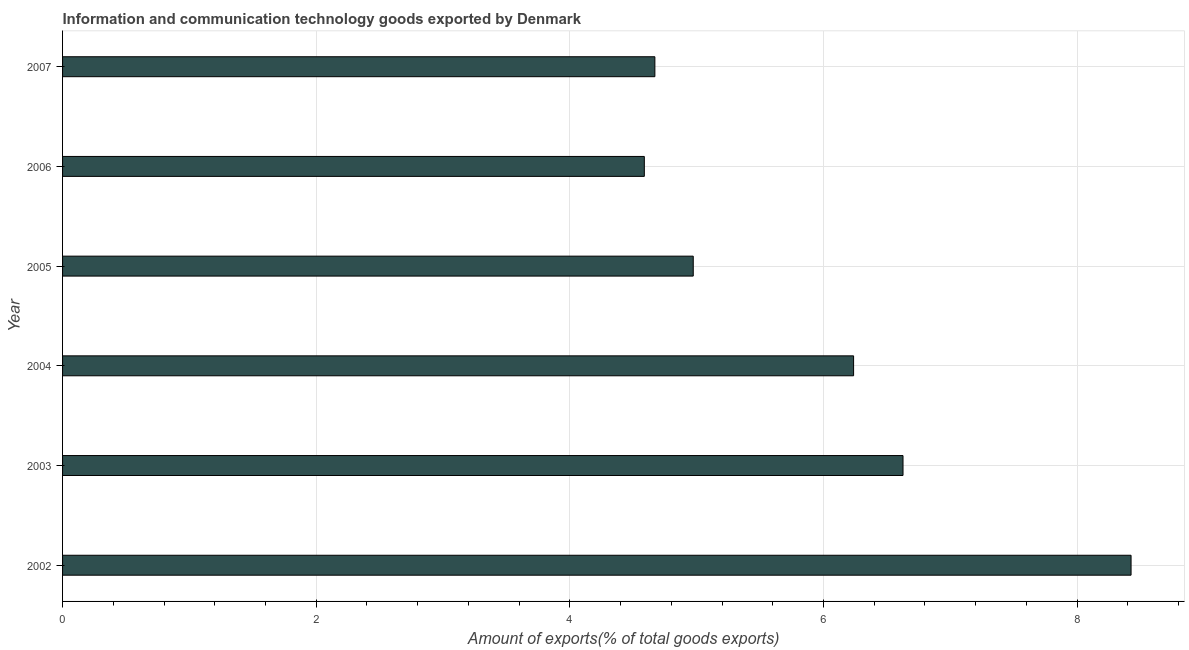Does the graph contain any zero values?
Make the answer very short. No. Does the graph contain grids?
Provide a succinct answer. Yes. What is the title of the graph?
Your answer should be compact. Information and communication technology goods exported by Denmark. What is the label or title of the X-axis?
Your answer should be very brief. Amount of exports(% of total goods exports). What is the amount of ict goods exports in 2006?
Offer a very short reply. 4.59. Across all years, what is the maximum amount of ict goods exports?
Your answer should be compact. 8.43. Across all years, what is the minimum amount of ict goods exports?
Your answer should be compact. 4.59. In which year was the amount of ict goods exports minimum?
Make the answer very short. 2006. What is the sum of the amount of ict goods exports?
Provide a succinct answer. 35.52. What is the difference between the amount of ict goods exports in 2003 and 2007?
Your answer should be very brief. 1.96. What is the average amount of ict goods exports per year?
Keep it short and to the point. 5.92. What is the median amount of ict goods exports?
Give a very brief answer. 5.61. In how many years, is the amount of ict goods exports greater than 2 %?
Your answer should be very brief. 6. What is the ratio of the amount of ict goods exports in 2002 to that in 2007?
Offer a terse response. 1.8. Is the amount of ict goods exports in 2002 less than that in 2005?
Your answer should be compact. No. What is the difference between the highest and the second highest amount of ict goods exports?
Your answer should be compact. 1.8. Is the sum of the amount of ict goods exports in 2005 and 2007 greater than the maximum amount of ict goods exports across all years?
Offer a very short reply. Yes. What is the difference between the highest and the lowest amount of ict goods exports?
Provide a succinct answer. 3.84. How many bars are there?
Offer a very short reply. 6. Are all the bars in the graph horizontal?
Offer a very short reply. Yes. How many years are there in the graph?
Your answer should be compact. 6. What is the Amount of exports(% of total goods exports) in 2002?
Give a very brief answer. 8.43. What is the Amount of exports(% of total goods exports) in 2003?
Give a very brief answer. 6.63. What is the Amount of exports(% of total goods exports) of 2004?
Your response must be concise. 6.24. What is the Amount of exports(% of total goods exports) in 2005?
Give a very brief answer. 4.97. What is the Amount of exports(% of total goods exports) in 2006?
Your response must be concise. 4.59. What is the Amount of exports(% of total goods exports) in 2007?
Keep it short and to the point. 4.67. What is the difference between the Amount of exports(% of total goods exports) in 2002 and 2003?
Make the answer very short. 1.8. What is the difference between the Amount of exports(% of total goods exports) in 2002 and 2004?
Give a very brief answer. 2.19. What is the difference between the Amount of exports(% of total goods exports) in 2002 and 2005?
Give a very brief answer. 3.45. What is the difference between the Amount of exports(% of total goods exports) in 2002 and 2006?
Make the answer very short. 3.84. What is the difference between the Amount of exports(% of total goods exports) in 2002 and 2007?
Keep it short and to the point. 3.75. What is the difference between the Amount of exports(% of total goods exports) in 2003 and 2004?
Your response must be concise. 0.39. What is the difference between the Amount of exports(% of total goods exports) in 2003 and 2005?
Your answer should be compact. 1.65. What is the difference between the Amount of exports(% of total goods exports) in 2003 and 2006?
Your answer should be compact. 2.04. What is the difference between the Amount of exports(% of total goods exports) in 2003 and 2007?
Your answer should be compact. 1.96. What is the difference between the Amount of exports(% of total goods exports) in 2004 and 2005?
Keep it short and to the point. 1.26. What is the difference between the Amount of exports(% of total goods exports) in 2004 and 2006?
Your answer should be very brief. 1.65. What is the difference between the Amount of exports(% of total goods exports) in 2004 and 2007?
Offer a terse response. 1.57. What is the difference between the Amount of exports(% of total goods exports) in 2005 and 2006?
Give a very brief answer. 0.39. What is the difference between the Amount of exports(% of total goods exports) in 2005 and 2007?
Your answer should be compact. 0.3. What is the difference between the Amount of exports(% of total goods exports) in 2006 and 2007?
Offer a very short reply. -0.08. What is the ratio of the Amount of exports(% of total goods exports) in 2002 to that in 2003?
Give a very brief answer. 1.27. What is the ratio of the Amount of exports(% of total goods exports) in 2002 to that in 2004?
Your answer should be compact. 1.35. What is the ratio of the Amount of exports(% of total goods exports) in 2002 to that in 2005?
Your answer should be compact. 1.69. What is the ratio of the Amount of exports(% of total goods exports) in 2002 to that in 2006?
Keep it short and to the point. 1.84. What is the ratio of the Amount of exports(% of total goods exports) in 2002 to that in 2007?
Ensure brevity in your answer.  1.8. What is the ratio of the Amount of exports(% of total goods exports) in 2003 to that in 2004?
Your answer should be very brief. 1.06. What is the ratio of the Amount of exports(% of total goods exports) in 2003 to that in 2005?
Offer a terse response. 1.33. What is the ratio of the Amount of exports(% of total goods exports) in 2003 to that in 2006?
Offer a terse response. 1.45. What is the ratio of the Amount of exports(% of total goods exports) in 2003 to that in 2007?
Provide a succinct answer. 1.42. What is the ratio of the Amount of exports(% of total goods exports) in 2004 to that in 2005?
Make the answer very short. 1.25. What is the ratio of the Amount of exports(% of total goods exports) in 2004 to that in 2006?
Keep it short and to the point. 1.36. What is the ratio of the Amount of exports(% of total goods exports) in 2004 to that in 2007?
Ensure brevity in your answer.  1.33. What is the ratio of the Amount of exports(% of total goods exports) in 2005 to that in 2006?
Your answer should be very brief. 1.08. What is the ratio of the Amount of exports(% of total goods exports) in 2005 to that in 2007?
Your response must be concise. 1.06. 